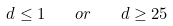<formula> <loc_0><loc_0><loc_500><loc_500>d \leq 1 \quad o r \quad d \geq 2 5</formula> 